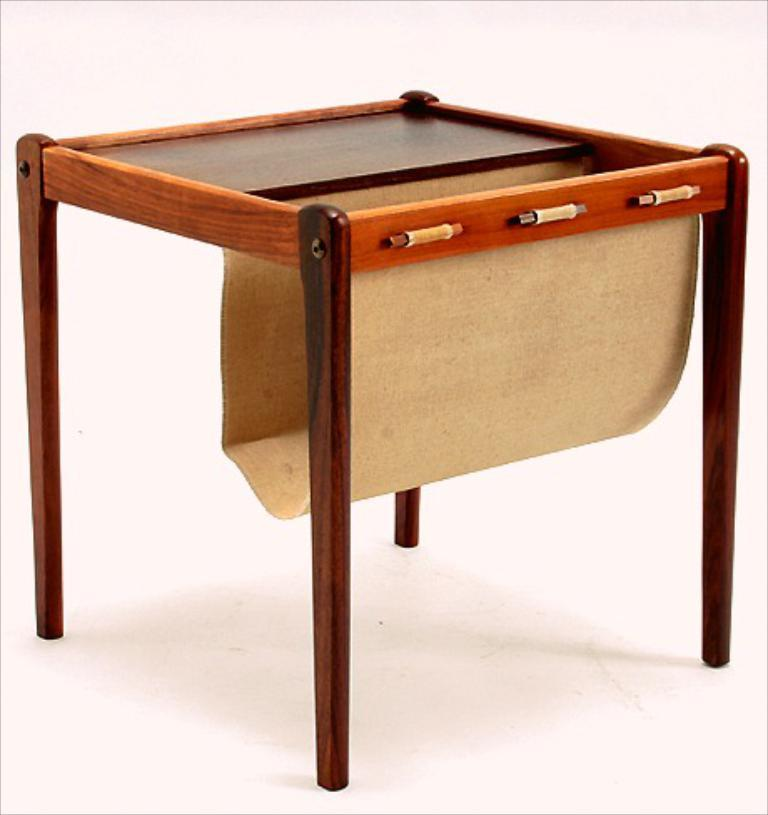What type of furniture is present in the image? There is a stool in the image. Where is the stool located in relation to the floor? The stool is kept on the floor. What color is the background behind the stool? The background of the stool is white. How does the stool attract the attention of the net in the image? There is no net present in the image, and therefore no interaction between the stool and a net can be observed. 